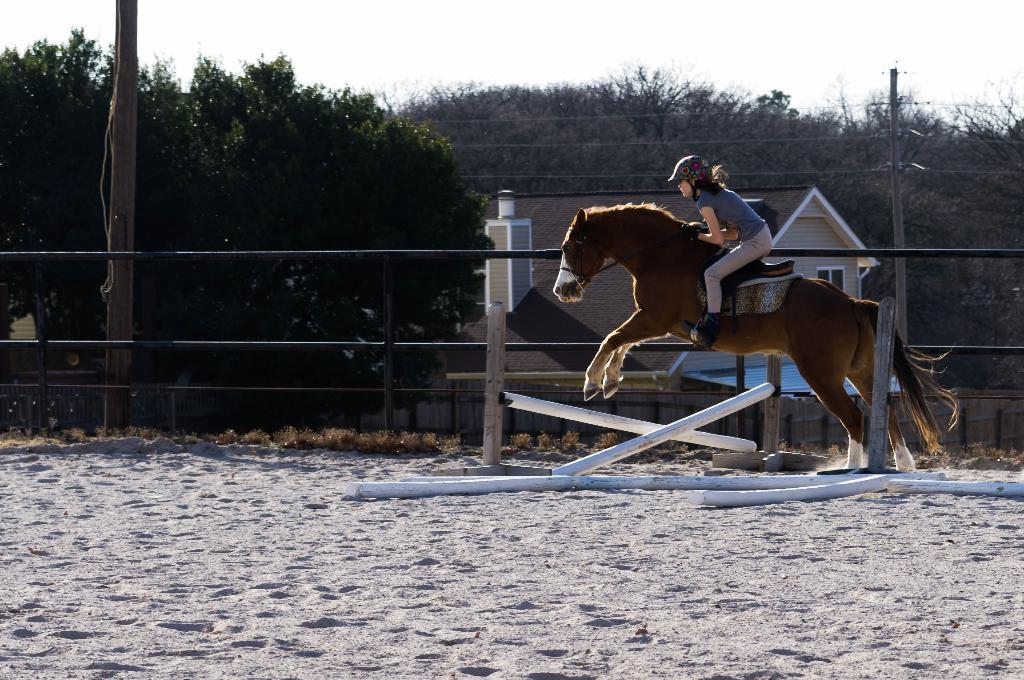Where was the image taken? The image was taken outside in a city. What is the woman in the image doing? The woman is riding a horse in the image. What protective gear is the woman wearing? The woman is wearing a helmet. What type of footwear is the woman wearing? The woman is wearing boots. What can be seen in the background of the image? There is a house, a tree, a mountain, the sky, and a pole in the background of the image. What is the reaction of the kitten to the woman riding the horse in the image? There is no kitten present in the image, so it is not possible to determine its reaction. What month is it in the image? The month is not mentioned or visible in the image, so it cannot be determined. 